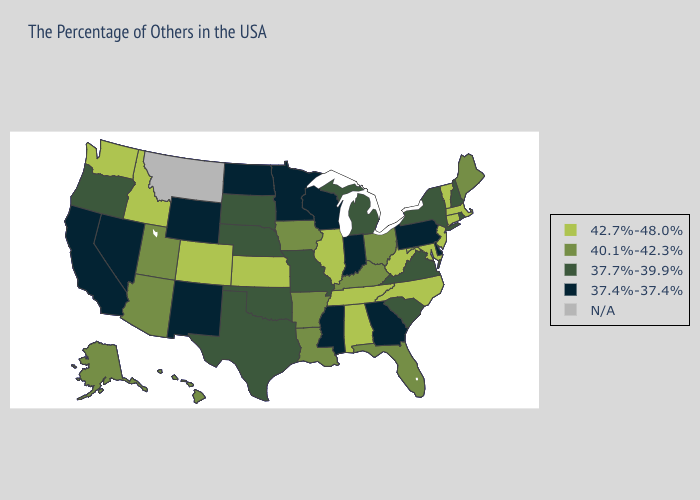What is the highest value in the USA?
Be succinct. 42.7%-48.0%. Does Iowa have the lowest value in the USA?
Be succinct. No. Name the states that have a value in the range 42.7%-48.0%?
Answer briefly. Massachusetts, Vermont, Connecticut, New Jersey, Maryland, North Carolina, West Virginia, Alabama, Tennessee, Illinois, Kansas, Colorado, Idaho, Washington. What is the lowest value in the Northeast?
Give a very brief answer. 37.4%-37.4%. What is the value of Illinois?
Be succinct. 42.7%-48.0%. Does Tennessee have the lowest value in the South?
Write a very short answer. No. What is the highest value in states that border Ohio?
Answer briefly. 42.7%-48.0%. Which states have the highest value in the USA?
Quick response, please. Massachusetts, Vermont, Connecticut, New Jersey, Maryland, North Carolina, West Virginia, Alabama, Tennessee, Illinois, Kansas, Colorado, Idaho, Washington. Does California have the lowest value in the USA?
Quick response, please. Yes. Name the states that have a value in the range 40.1%-42.3%?
Be succinct. Maine, Ohio, Florida, Kentucky, Louisiana, Arkansas, Iowa, Utah, Arizona, Alaska, Hawaii. Does Ohio have the lowest value in the MidWest?
Quick response, please. No. Among the states that border Oklahoma , does Kansas have the lowest value?
Give a very brief answer. No. Among the states that border Wisconsin , does Iowa have the lowest value?
Quick response, please. No. What is the highest value in the USA?
Concise answer only. 42.7%-48.0%. 